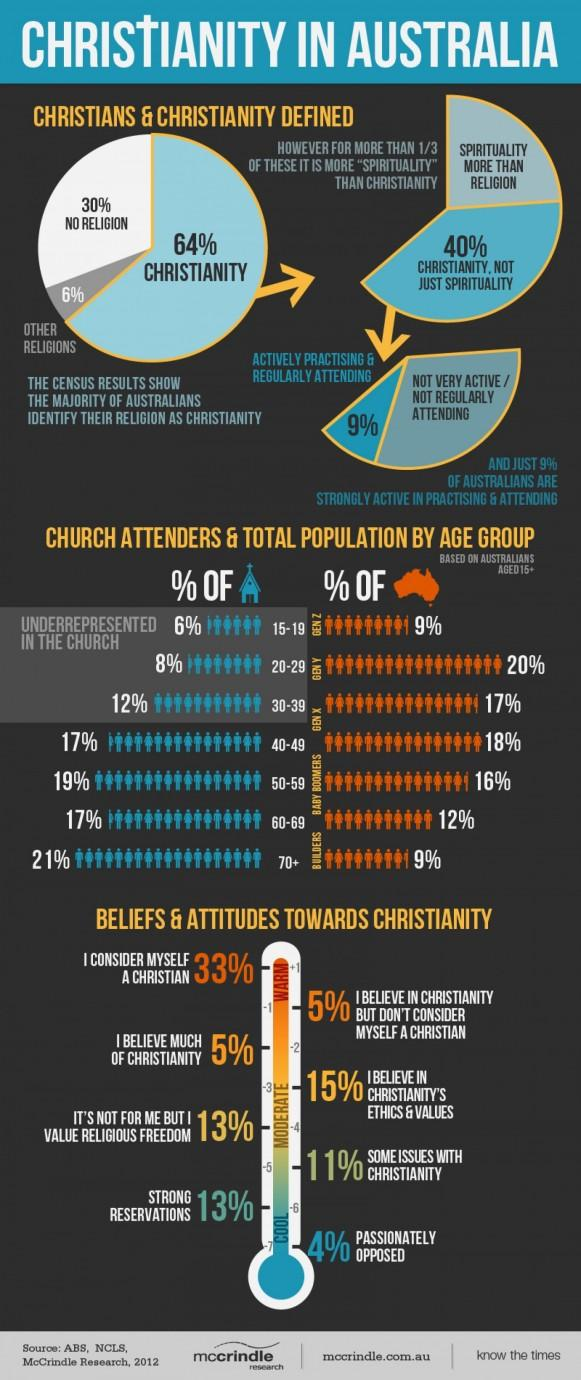Highlight a few significant elements in this photo. According to a survey conducted in Australia, it was found that 24% of Christian people are more spiritual than religious. According to a recent survey, only 36% of people in Australia are not Christians. In Christian communities, attitudes and beliefs are often divided into three distinct modes: cool, moderate, and warm. There are three distinct modes in which Christian people's attitudes and beliefs are divided. The age group that has the lowest population and the highest percentage in attending mass is 70 years old and above. 